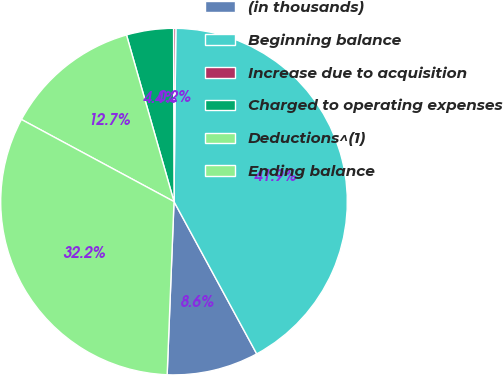Convert chart. <chart><loc_0><loc_0><loc_500><loc_500><pie_chart><fcel>(in thousands)<fcel>Beginning balance<fcel>Increase due to acquisition<fcel>Charged to operating expenses<fcel>Deductions^(1)<fcel>Ending balance<nl><fcel>8.55%<fcel>41.91%<fcel>0.21%<fcel>4.38%<fcel>12.72%<fcel>32.23%<nl></chart> 